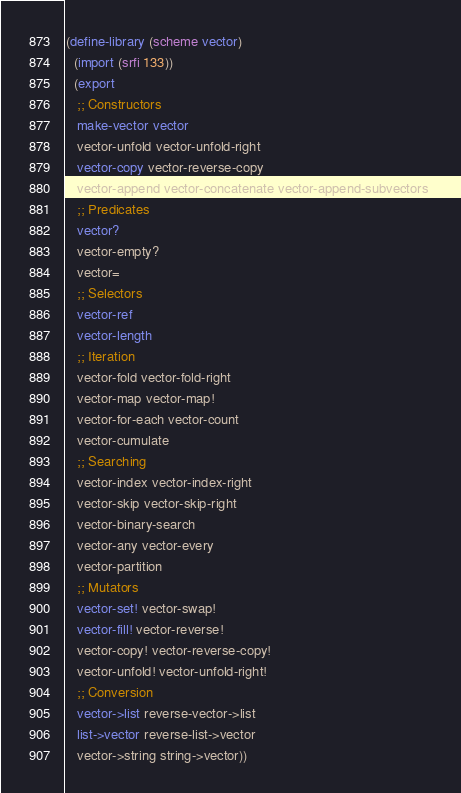Convert code to text. <code><loc_0><loc_0><loc_500><loc_500><_Scheme_>
(define-library (scheme vector)
  (import (srfi 133))
  (export
   ;; Constructors
   make-vector vector 
   vector-unfold vector-unfold-right 
   vector-copy vector-reverse-copy 
   vector-append vector-concatenate vector-append-subvectors 
   ;; Predicates 
   vector? 
   vector-empty? 
   vector= 
   ;; Selectors 
   vector-ref 
   vector-length 
   ;; Iteration 
   vector-fold vector-fold-right 
   vector-map vector-map! 
   vector-for-each vector-count 
   vector-cumulate 
   ;; Searching 
   vector-index vector-index-right 
   vector-skip vector-skip-right 
   vector-binary-search 
   vector-any vector-every 
   vector-partition 
   ;; Mutators 
   vector-set! vector-swap! 
   vector-fill! vector-reverse! 
   vector-copy! vector-reverse-copy! 
   vector-unfold! vector-unfold-right! 
   ;; Conversion 
   vector->list reverse-vector->list 
   list->vector reverse-list->vector 
   vector->string string->vector))
</code> 